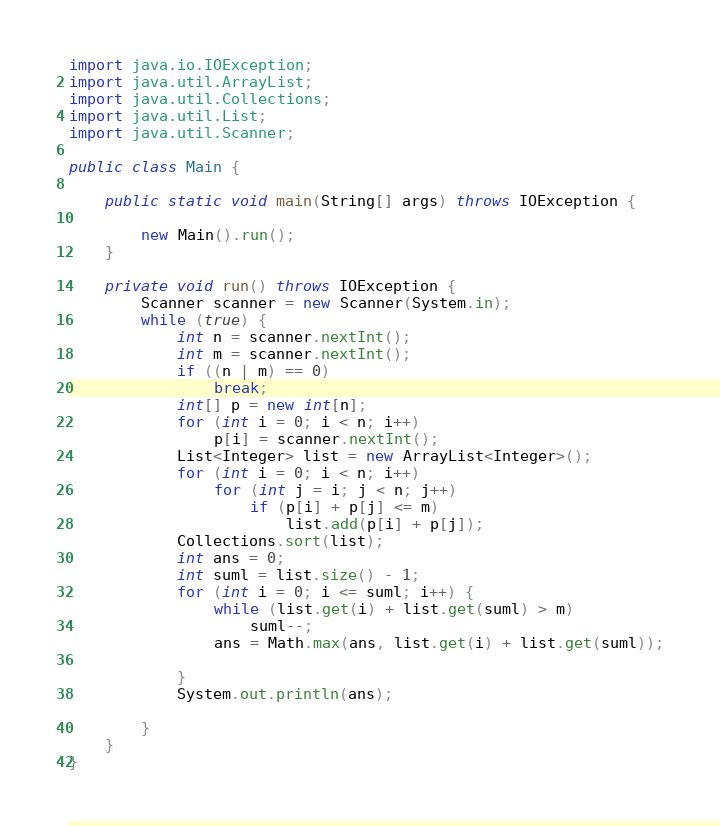<code> <loc_0><loc_0><loc_500><loc_500><_Java_>
import java.io.IOException;
import java.util.ArrayList;
import java.util.Collections;
import java.util.List;
import java.util.Scanner;

public class Main {

	public static void main(String[] args) throws IOException {

		new Main().run();
	}

	private void run() throws IOException {
		Scanner scanner = new Scanner(System.in);
		while (true) {
			int n = scanner.nextInt();
			int m = scanner.nextInt();
			if ((n | m) == 0)
				break;
			int[] p = new int[n];
			for (int i = 0; i < n; i++)
				p[i] = scanner.nextInt();
			List<Integer> list = new ArrayList<Integer>();
			for (int i = 0; i < n; i++)
				for (int j = i; j < n; j++)
					if (p[i] + p[j] <= m)
						list.add(p[i] + p[j]);
			Collections.sort(list);
			int ans = 0;
			int suml = list.size() - 1;
			for (int i = 0; i <= suml; i++) {
				while (list.get(i) + list.get(suml) > m)
					suml--;
				ans = Math.max(ans, list.get(i) + list.get(suml));

			}
			System.out.println(ans);

		}
	}
}</code> 